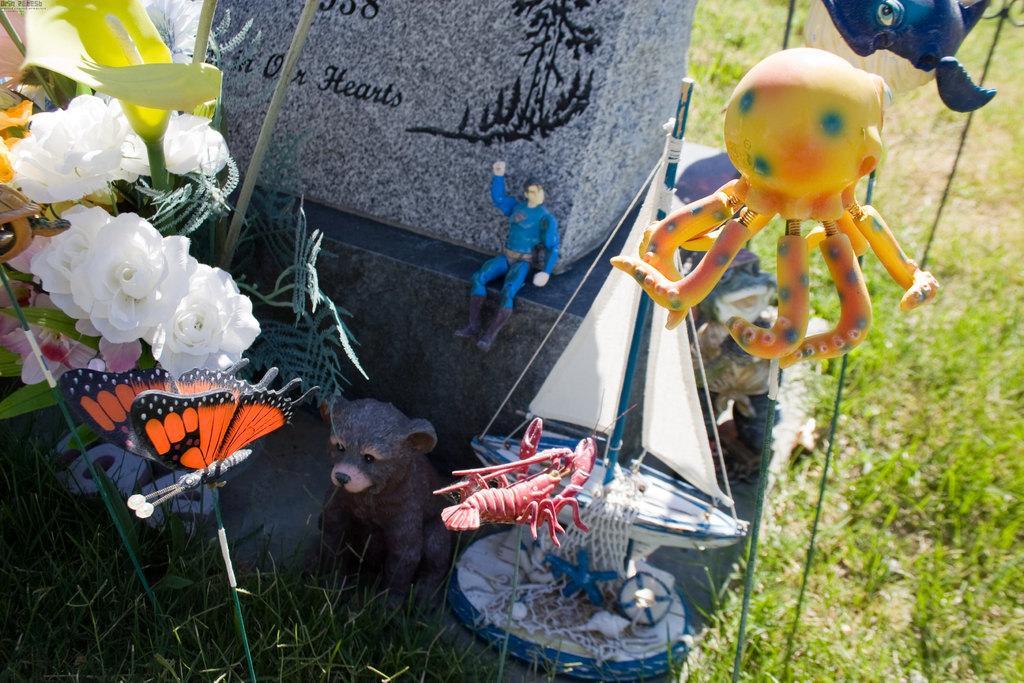In one or two sentences, can you explain what this image depicts? In the foreground of this image, there are few toys, a flower vase on the left and also a stone like an object. On the right, there is the grass. 